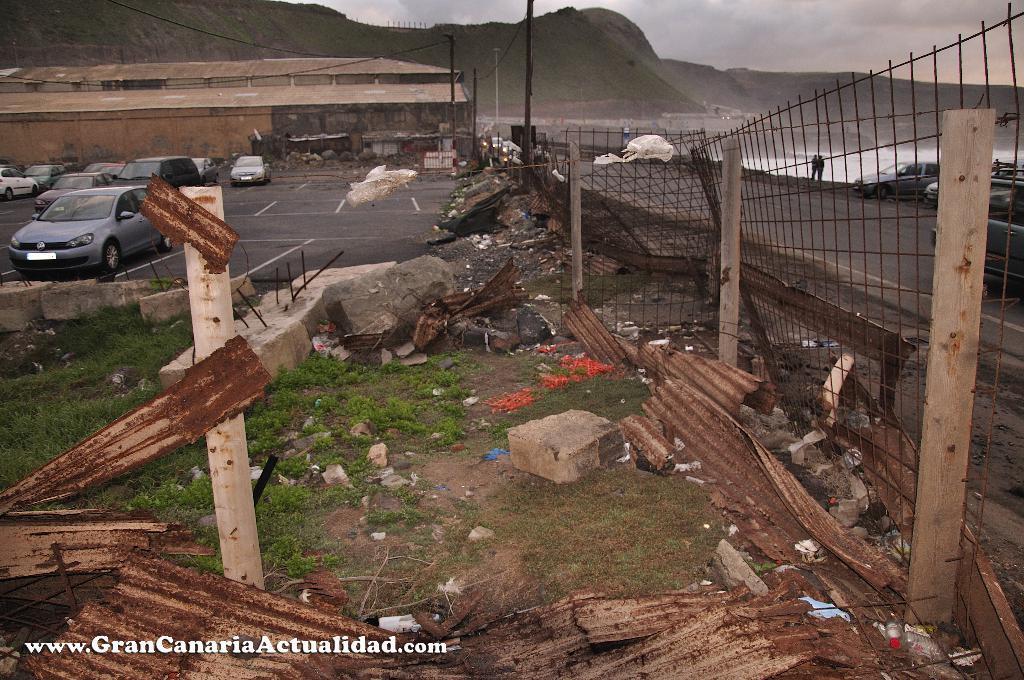Could you give a brief overview of what you see in this image? In this image we can see grass, poles, welded wire mesh, roof sheets, stones, and some objects. There are cars, sheds, wires, road, people, and water. In the background we can see mountain and sky with clouds. 